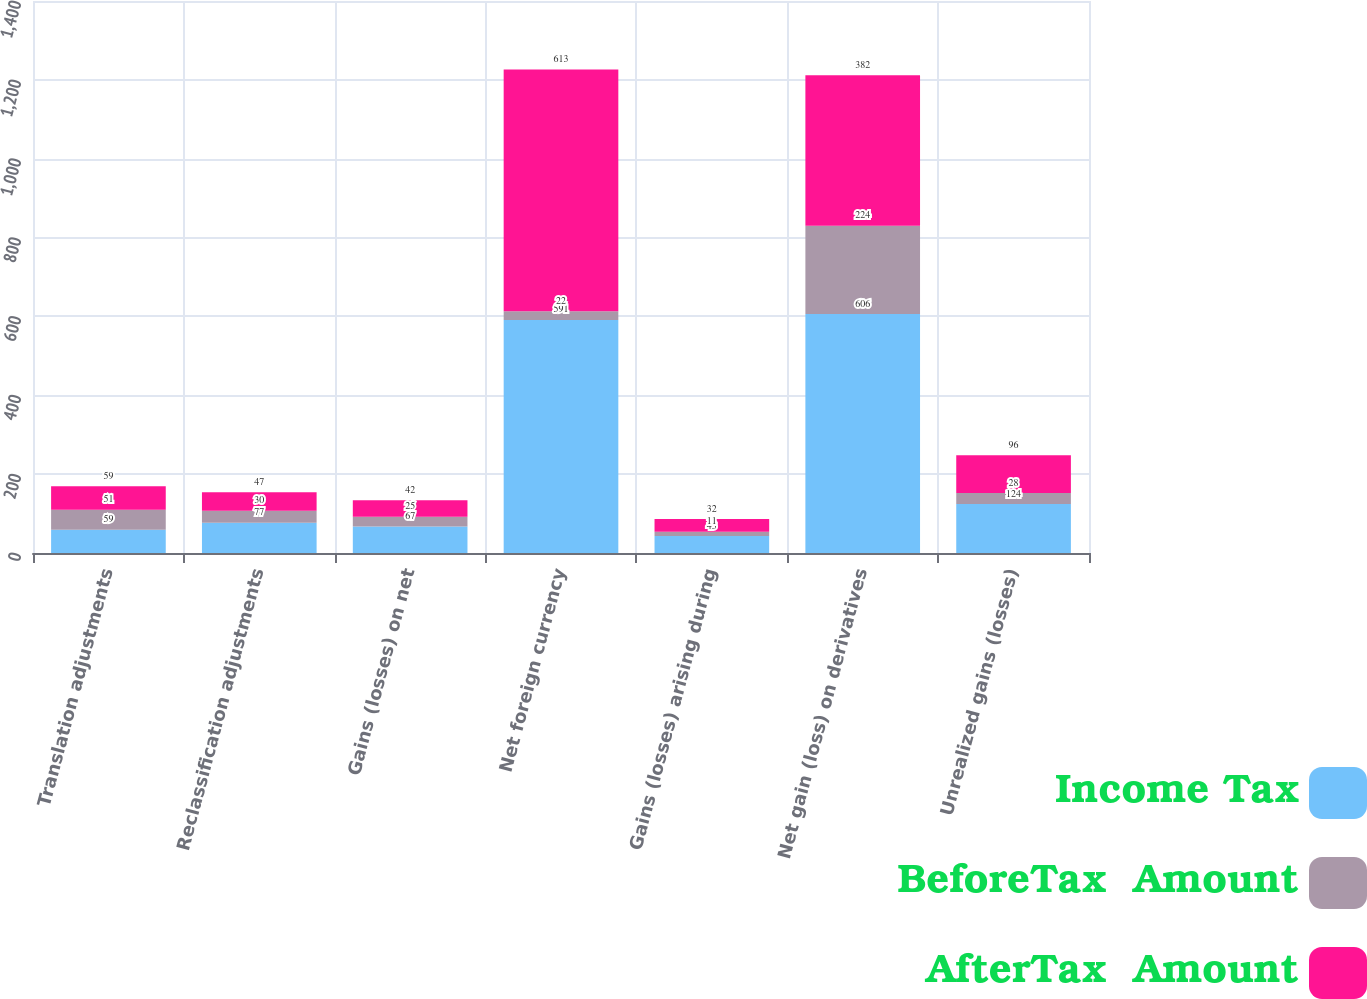<chart> <loc_0><loc_0><loc_500><loc_500><stacked_bar_chart><ecel><fcel>Translation adjustments<fcel>Reclassification adjustments<fcel>Gains (losses) on net<fcel>Net foreign currency<fcel>Gains (losses) arising during<fcel>Net gain (loss) on derivatives<fcel>Unrealized gains (losses)<nl><fcel>Income Tax<fcel>59<fcel>77<fcel>67<fcel>591<fcel>43<fcel>606<fcel>124<nl><fcel>BeforeTax  Amount<fcel>51<fcel>30<fcel>25<fcel>22<fcel>11<fcel>224<fcel>28<nl><fcel>AfterTax  Amount<fcel>59<fcel>47<fcel>42<fcel>613<fcel>32<fcel>382<fcel>96<nl></chart> 